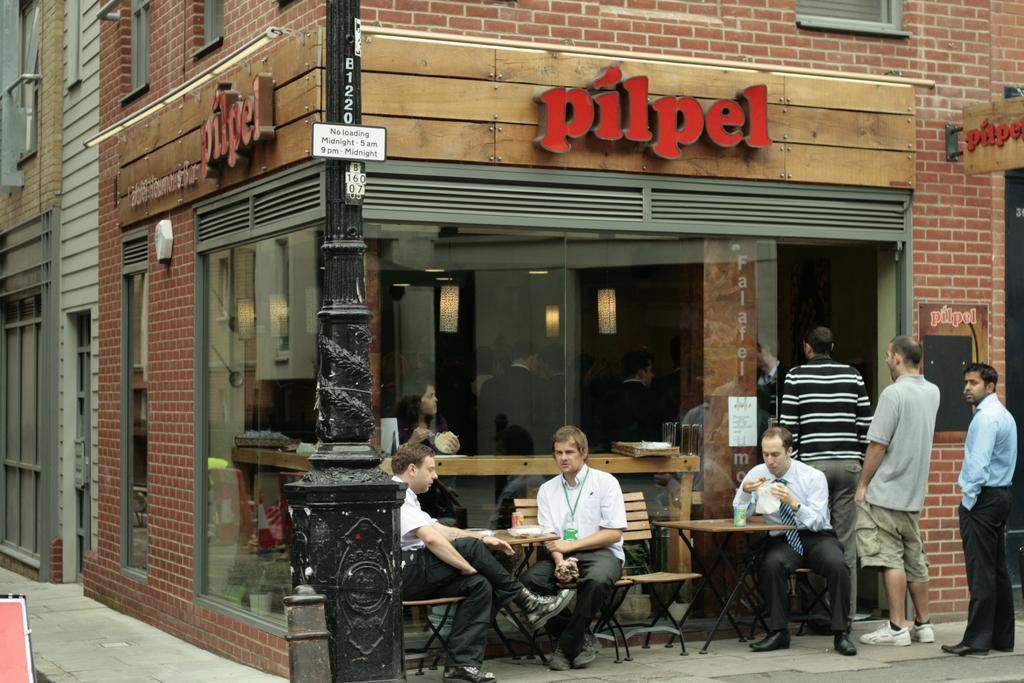Please provide a concise description of this image. In the image there is a cafe and outside the cafe there are few people and some of them are sitting around the tables, there is a pole in front of the cafe. 